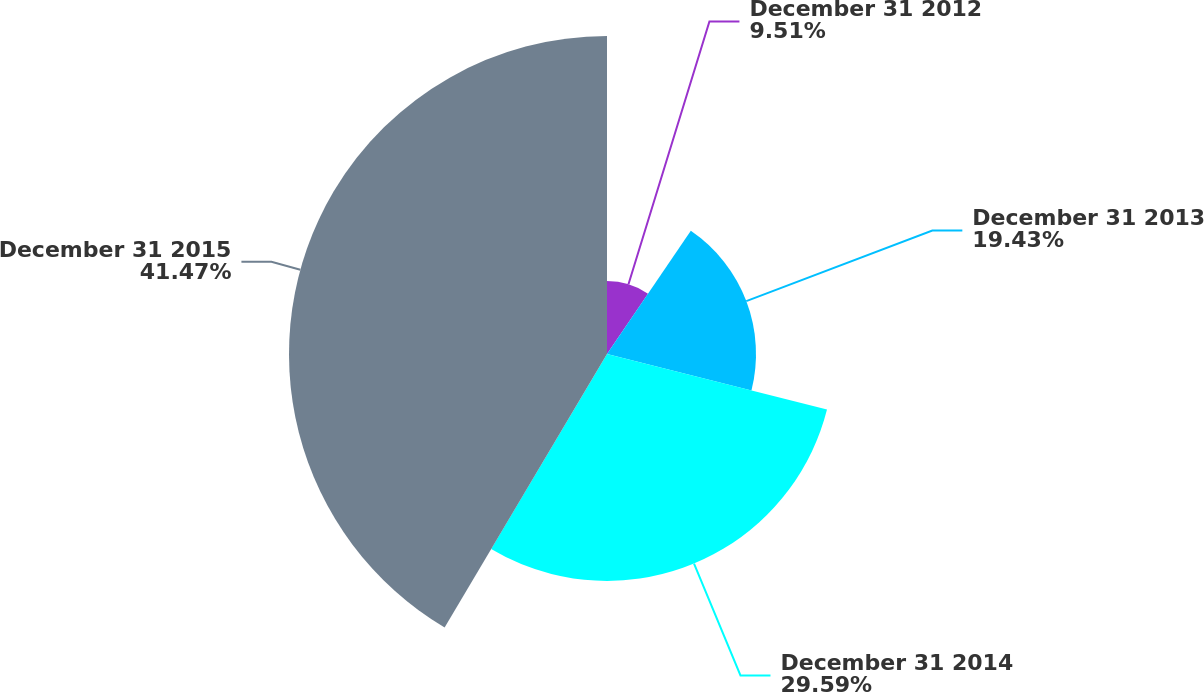<chart> <loc_0><loc_0><loc_500><loc_500><pie_chart><fcel>December 31 2012<fcel>December 31 2013<fcel>December 31 2014<fcel>December 31 2015<nl><fcel>9.51%<fcel>19.43%<fcel>29.59%<fcel>41.47%<nl></chart> 